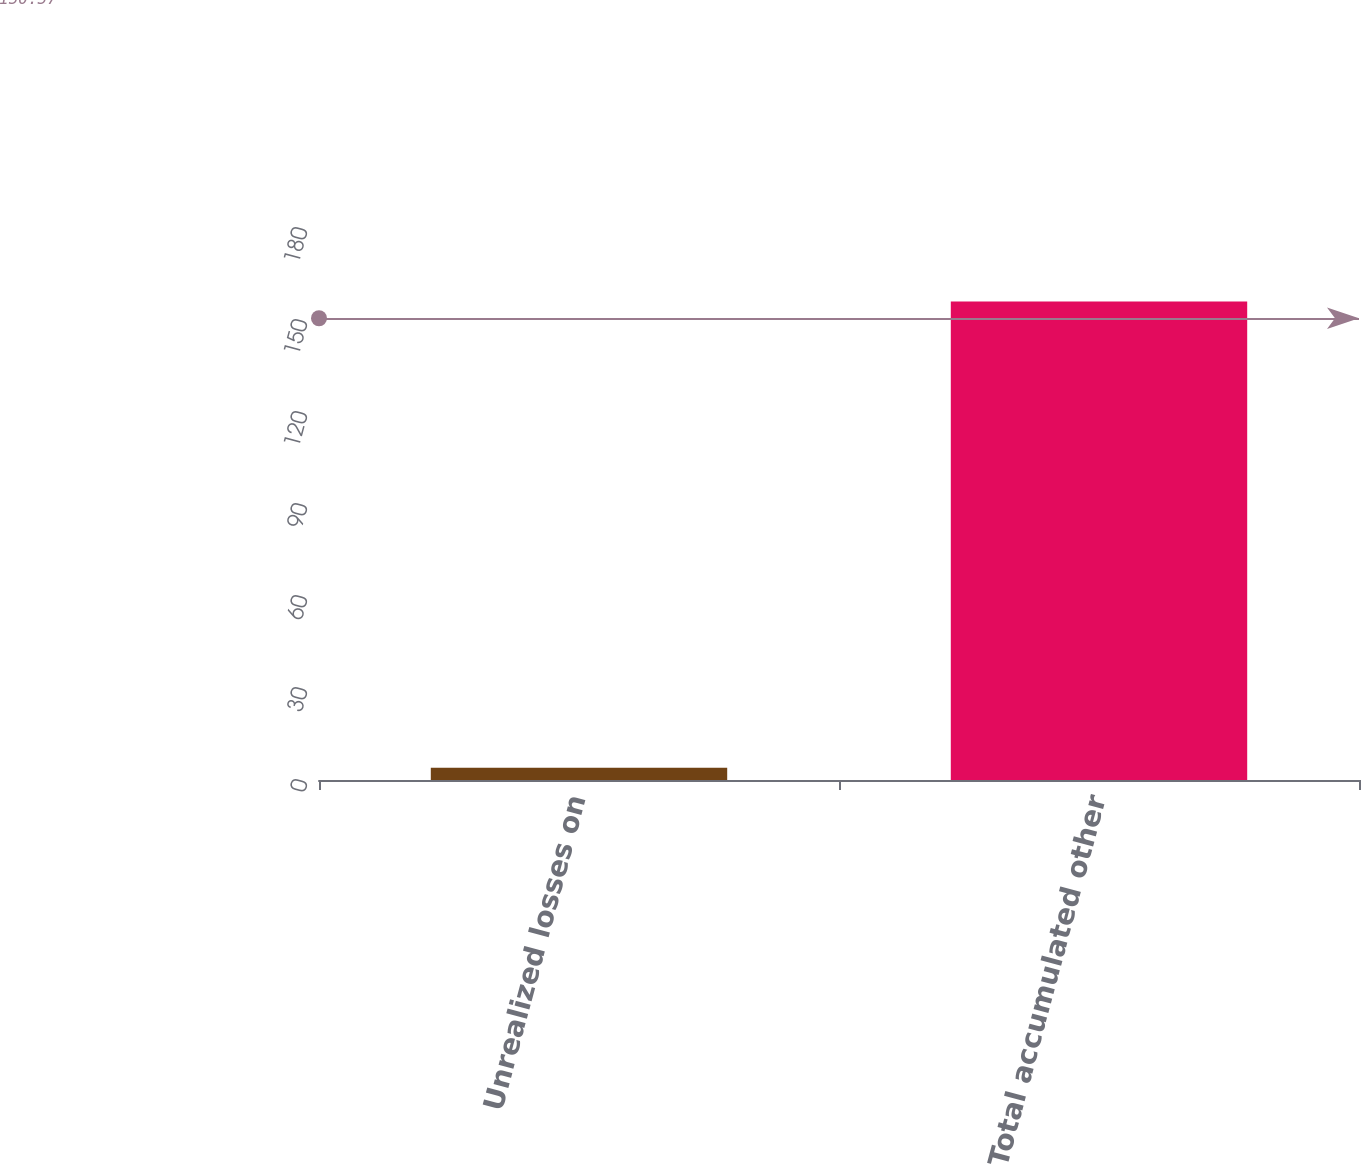Convert chart. <chart><loc_0><loc_0><loc_500><loc_500><bar_chart><fcel>Unrealized losses on<fcel>Total accumulated other<nl><fcel>4<fcel>156<nl></chart> 